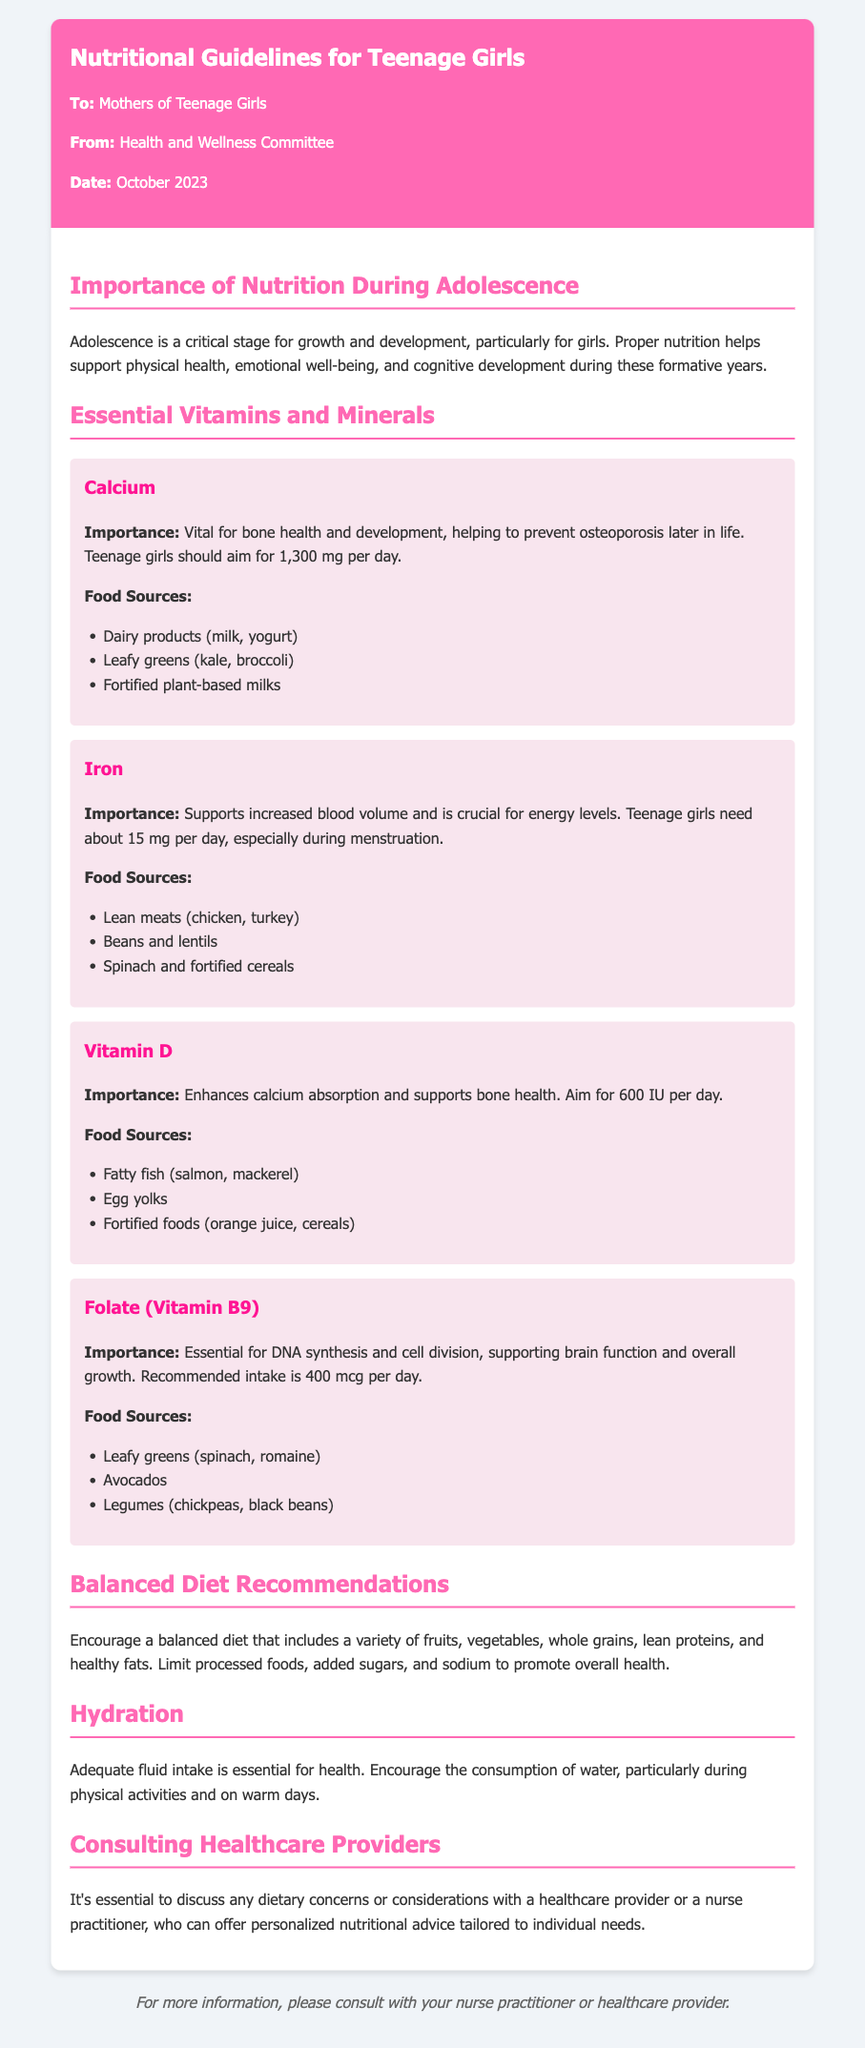What is the daily recommended intake of Calcium for teenage girls? The recommended intake of Calcium for teenage girls is provided in the document as 1,300 mg per day.
Answer: 1,300 mg What is the primary importance of Iron for teenage girls? The document states that Iron supports increased blood volume and is crucial for energy levels.
Answer: Supports increased blood volume What food source is suggested for Vitamin D? The document lists food sources for Vitamin D, and one example is fatty fish.
Answer: Fatty fish How much Folate (Vitamin B9) is recommended daily? The document specifies that the recommended intake of Folate is 400 mcg per day.
Answer: 400 mcg What is a key recommendation for maintaining a balanced diet according to the memo? The document advises to encourage a balanced diet that includes a variety of fruits, vegetables, whole grains, lean proteins, and healthy fats.
Answer: Variety of fruits, vegetables, whole grains, lean proteins, and healthy fats What role do nurse practitioners play according to the document? The document states that it is essential to discuss dietary concerns with a healthcare provider or nurse practitioner for personalized advice.
Answer: Personalized nutritional advice How much Vitamin D should teenage girls aim for daily? The document mentions that teenage girls should aim for 600 IU of Vitamin D per day.
Answer: 600 IU What is the importance of hydration mentioned in the memo? The memo states that adequate fluid intake is essential for health and encourages water consumption.
Answer: Essential for health 